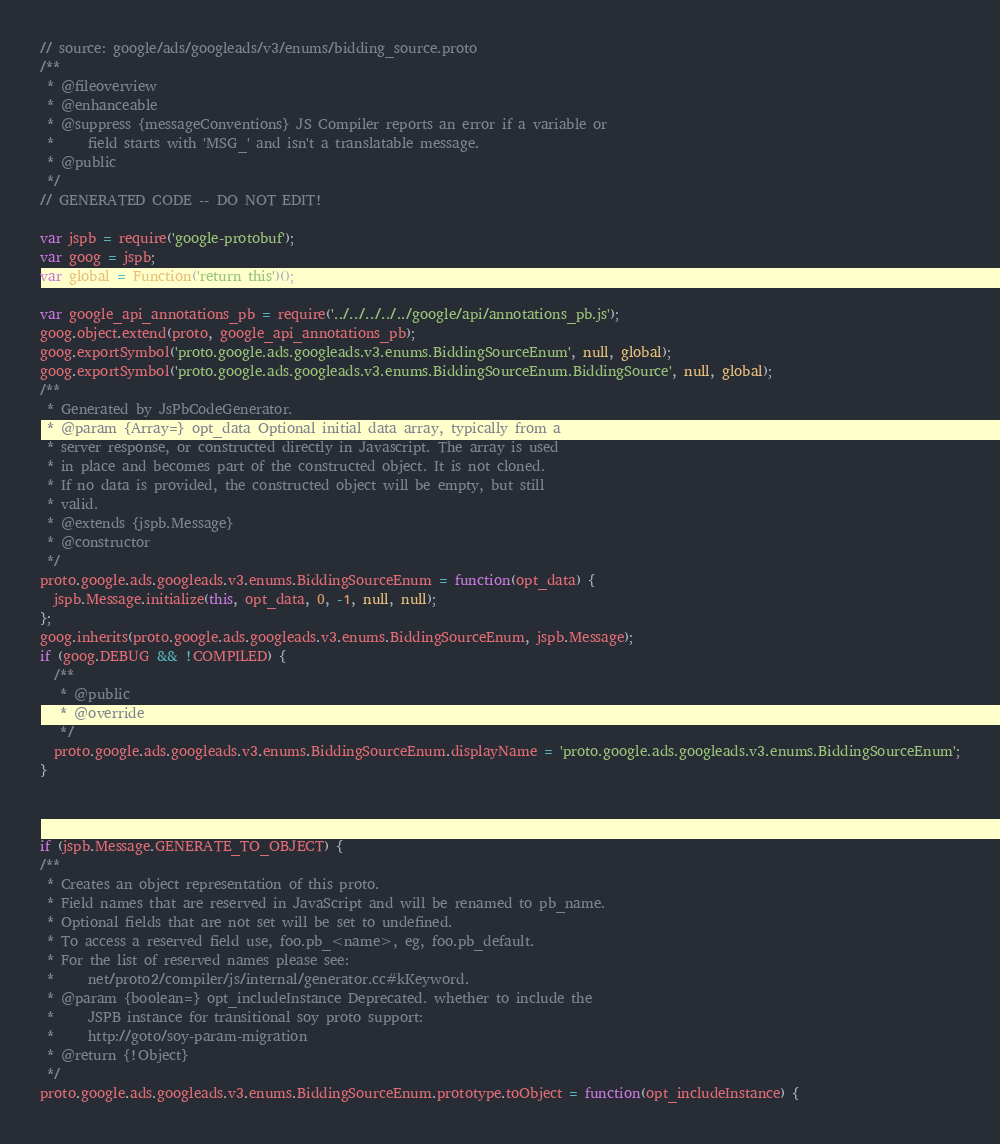Convert code to text. <code><loc_0><loc_0><loc_500><loc_500><_JavaScript_>// source: google/ads/googleads/v3/enums/bidding_source.proto
/**
 * @fileoverview
 * @enhanceable
 * @suppress {messageConventions} JS Compiler reports an error if a variable or
 *     field starts with 'MSG_' and isn't a translatable message.
 * @public
 */
// GENERATED CODE -- DO NOT EDIT!

var jspb = require('google-protobuf');
var goog = jspb;
var global = Function('return this')();

var google_api_annotations_pb = require('../../../../../google/api/annotations_pb.js');
goog.object.extend(proto, google_api_annotations_pb);
goog.exportSymbol('proto.google.ads.googleads.v3.enums.BiddingSourceEnum', null, global);
goog.exportSymbol('proto.google.ads.googleads.v3.enums.BiddingSourceEnum.BiddingSource', null, global);
/**
 * Generated by JsPbCodeGenerator.
 * @param {Array=} opt_data Optional initial data array, typically from a
 * server response, or constructed directly in Javascript. The array is used
 * in place and becomes part of the constructed object. It is not cloned.
 * If no data is provided, the constructed object will be empty, but still
 * valid.
 * @extends {jspb.Message}
 * @constructor
 */
proto.google.ads.googleads.v3.enums.BiddingSourceEnum = function(opt_data) {
  jspb.Message.initialize(this, opt_data, 0, -1, null, null);
};
goog.inherits(proto.google.ads.googleads.v3.enums.BiddingSourceEnum, jspb.Message);
if (goog.DEBUG && !COMPILED) {
  /**
   * @public
   * @override
   */
  proto.google.ads.googleads.v3.enums.BiddingSourceEnum.displayName = 'proto.google.ads.googleads.v3.enums.BiddingSourceEnum';
}



if (jspb.Message.GENERATE_TO_OBJECT) {
/**
 * Creates an object representation of this proto.
 * Field names that are reserved in JavaScript and will be renamed to pb_name.
 * Optional fields that are not set will be set to undefined.
 * To access a reserved field use, foo.pb_<name>, eg, foo.pb_default.
 * For the list of reserved names please see:
 *     net/proto2/compiler/js/internal/generator.cc#kKeyword.
 * @param {boolean=} opt_includeInstance Deprecated. whether to include the
 *     JSPB instance for transitional soy proto support:
 *     http://goto/soy-param-migration
 * @return {!Object}
 */
proto.google.ads.googleads.v3.enums.BiddingSourceEnum.prototype.toObject = function(opt_includeInstance) {</code> 